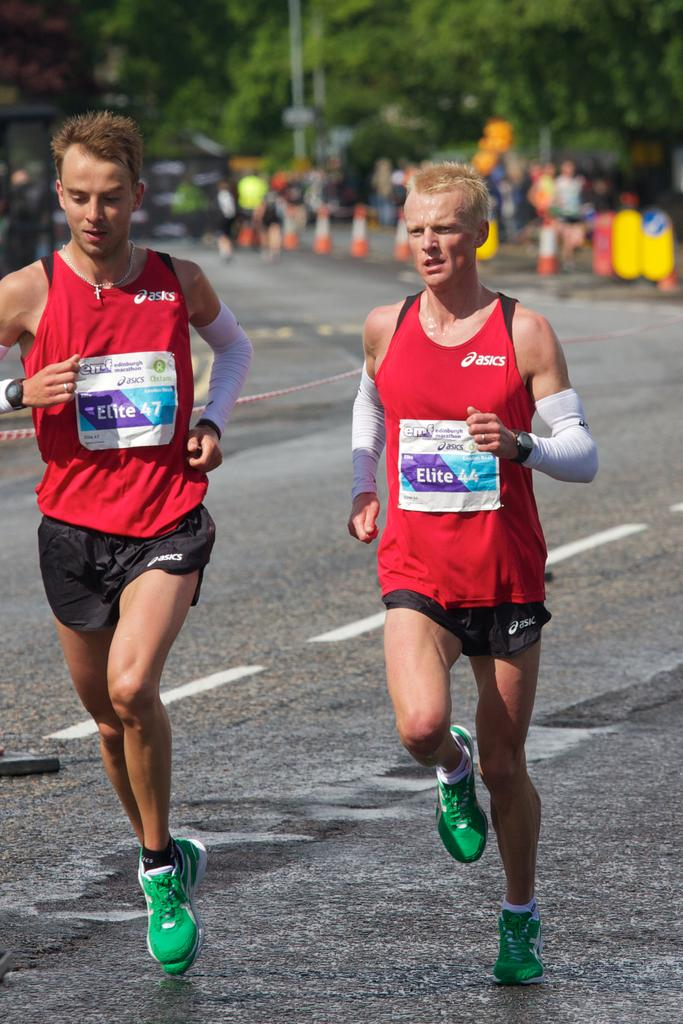<image>
Share a concise interpretation of the image provided. Two men wearing Asics shirts race down the road wearing green shoes 